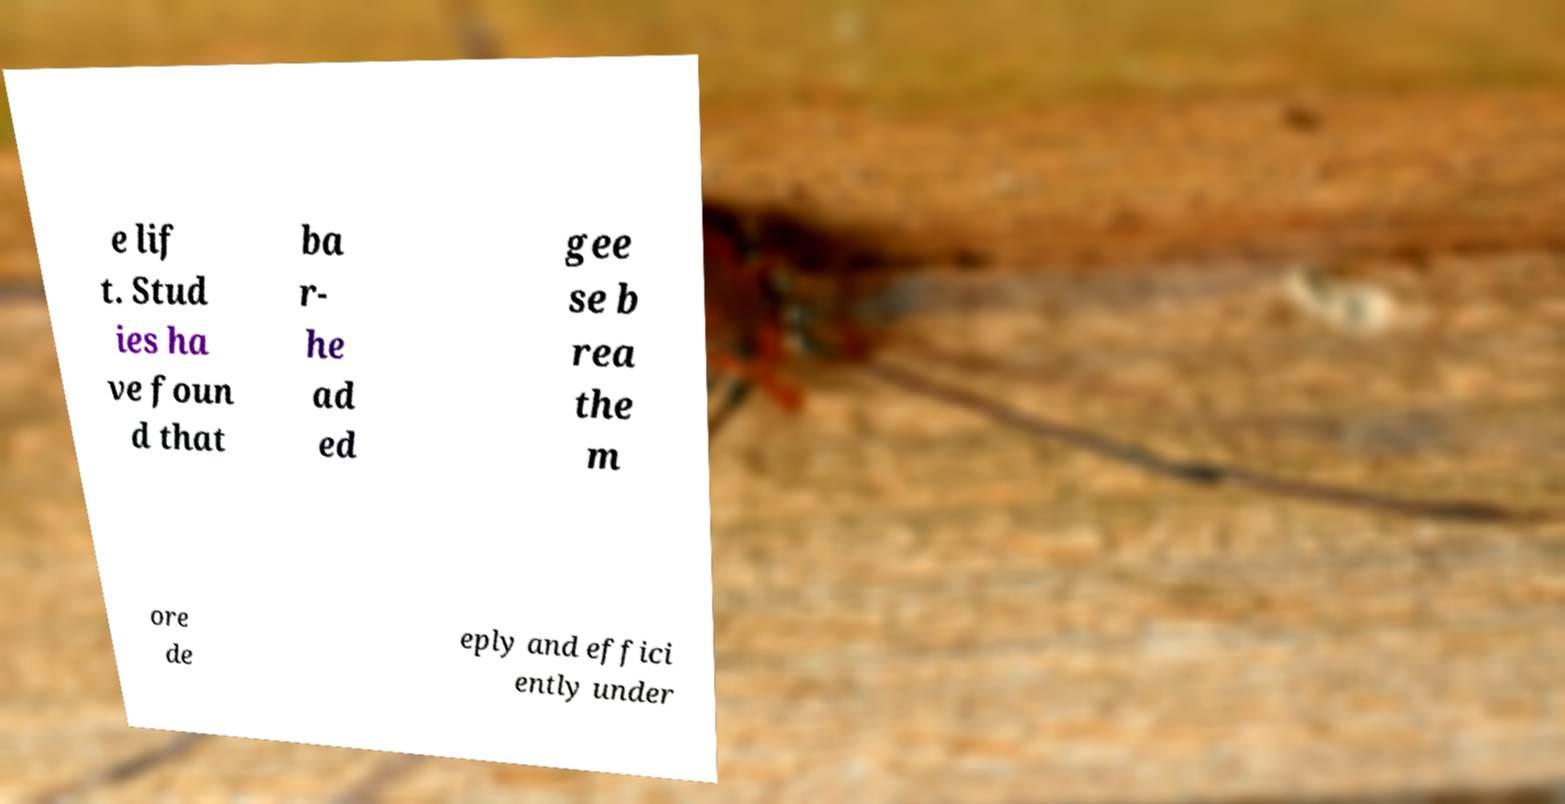Could you extract and type out the text from this image? e lif t. Stud ies ha ve foun d that ba r- he ad ed gee se b rea the m ore de eply and effici ently under 